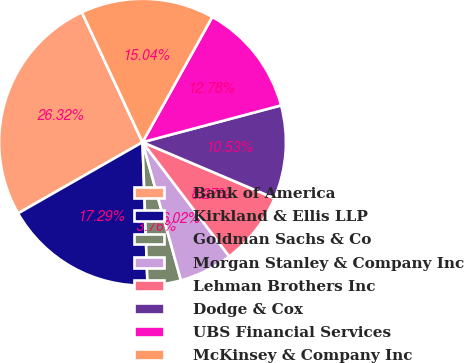Convert chart to OTSL. <chart><loc_0><loc_0><loc_500><loc_500><pie_chart><fcel>Bank of America<fcel>Kirkland & Ellis LLP<fcel>Goldman Sachs & Co<fcel>Morgan Stanley & Company Inc<fcel>Lehman Brothers Inc<fcel>Dodge & Cox<fcel>UBS Financial Services<fcel>McKinsey & Company Inc<nl><fcel>26.32%<fcel>17.29%<fcel>3.76%<fcel>6.02%<fcel>8.27%<fcel>10.53%<fcel>12.78%<fcel>15.04%<nl></chart> 